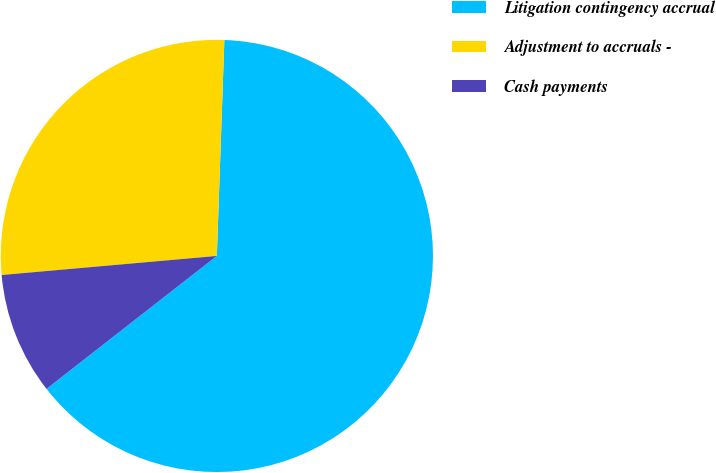Convert chart. <chart><loc_0><loc_0><loc_500><loc_500><pie_chart><fcel>Litigation contingency accrual<fcel>Adjustment to accruals -<fcel>Cash payments<nl><fcel>63.9%<fcel>26.96%<fcel>9.14%<nl></chart> 